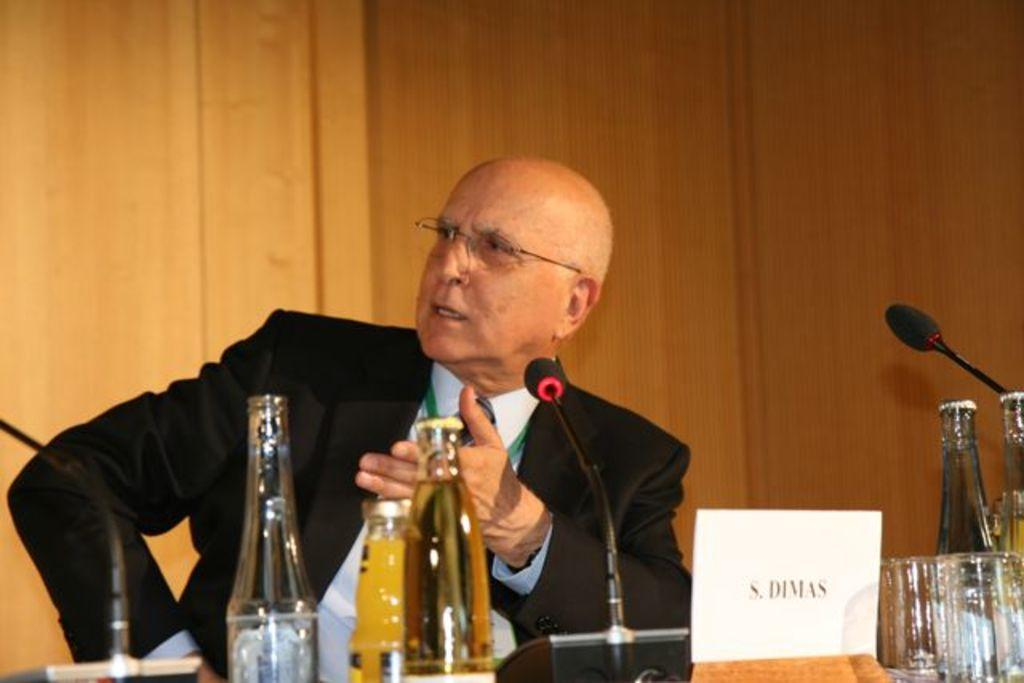What is the position of the man in the image? The man is seated in the image. What can be seen on the man's face? The man is wearing spectacles in the image. What objects are in front of the man? There are bottles, microphones, and a name board in front of the man. What is present on the table? There are glasses on the table. What type of crate is being used to transport the wind in the image? There is no crate or wind present in the image. What kind of board is being used to create a path for the board game in the image? There is no board game or board present in the image. 